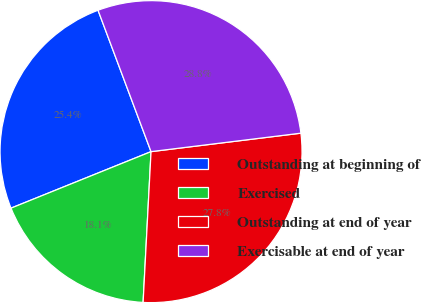<chart> <loc_0><loc_0><loc_500><loc_500><pie_chart><fcel>Outstanding at beginning of<fcel>Exercised<fcel>Outstanding at end of year<fcel>Exercisable at end of year<nl><fcel>25.4%<fcel>18.06%<fcel>27.79%<fcel>28.76%<nl></chart> 